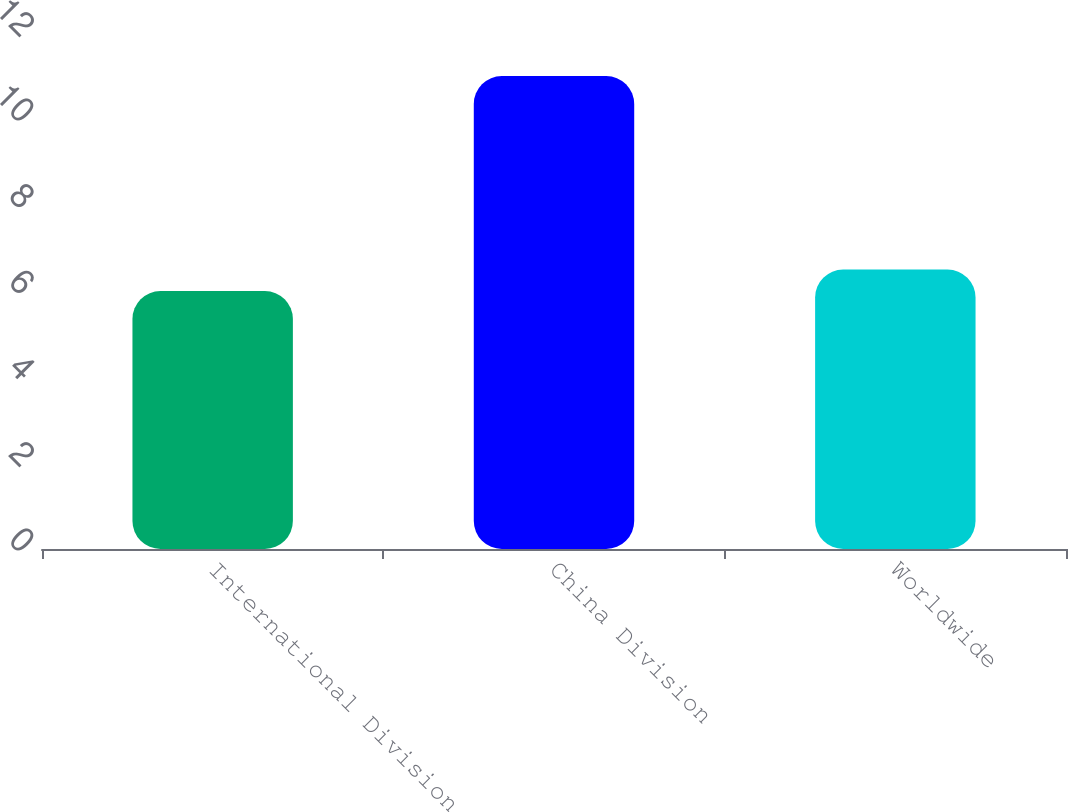Convert chart to OTSL. <chart><loc_0><loc_0><loc_500><loc_500><bar_chart><fcel>International Division<fcel>China Division<fcel>Worldwide<nl><fcel>6<fcel>11<fcel>6.5<nl></chart> 